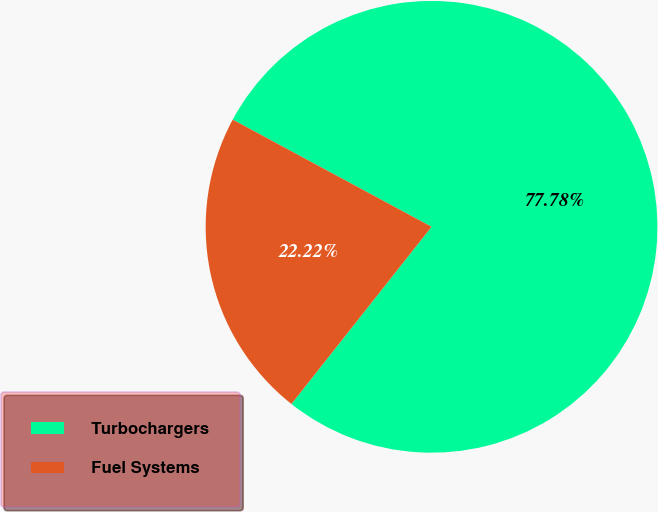Convert chart. <chart><loc_0><loc_0><loc_500><loc_500><pie_chart><fcel>Turbochargers<fcel>Fuel Systems<nl><fcel>77.78%<fcel>22.22%<nl></chart> 